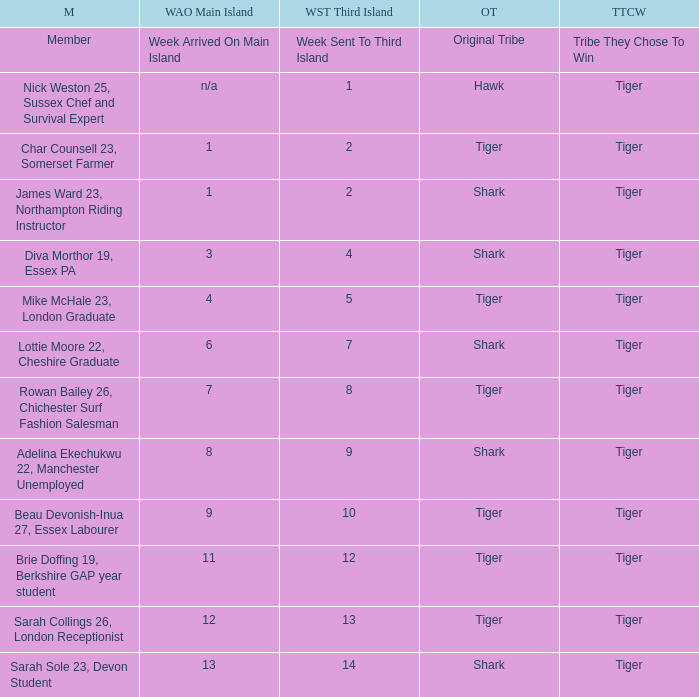Could you parse the entire table? {'header': ['M', 'WAO Main Island', 'WST Third Island', 'OT', 'TTCW'], 'rows': [['Member', 'Week Arrived On Main Island', 'Week Sent To Third Island', 'Original Tribe', 'Tribe They Chose To Win'], ['Nick Weston 25, Sussex Chef and Survival Expert', 'n/a', '1', 'Hawk', 'Tiger'], ['Char Counsell 23, Somerset Farmer', '1', '2', 'Tiger', 'Tiger'], ['James Ward 23, Northampton Riding Instructor', '1', '2', 'Shark', 'Tiger'], ['Diva Morthor 19, Essex PA', '3', '4', 'Shark', 'Tiger'], ['Mike McHale 23, London Graduate', '4', '5', 'Tiger', 'Tiger'], ['Lottie Moore 22, Cheshire Graduate', '6', '7', 'Shark', 'Tiger'], ['Rowan Bailey 26, Chichester Surf Fashion Salesman', '7', '8', 'Tiger', 'Tiger'], ['Adelina Ekechukwu 22, Manchester Unemployed', '8', '9', 'Shark', 'Tiger'], ['Beau Devonish-Inua 27, Essex Labourer', '9', '10', 'Tiger', 'Tiger'], ['Brie Doffing 19, Berkshire GAP year student', '11', '12', 'Tiger', 'Tiger'], ['Sarah Collings 26, London Receptionist', '12', '13', 'Tiger', 'Tiger'], ['Sarah Sole 23, Devon Student', '13', '14', 'Shark', 'Tiger']]} What week did the member who's original tribe was shark and who was sent to the third island on week 14 arrive on the main island? 13.0. 